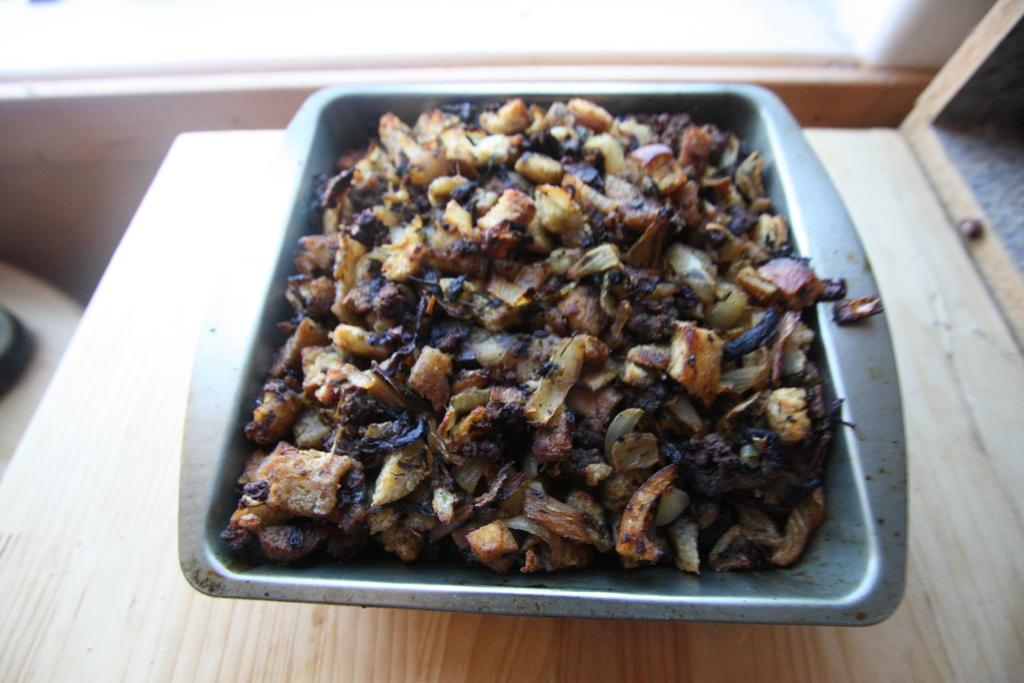What is in the bowl that is visible in the image? There is a bowl containing food in the image. What is the bowl placed on in the image? The bowl is placed on a wooden surface. How many pears are visible on the sheet in the image? There are no pears or sheets present in the image. 